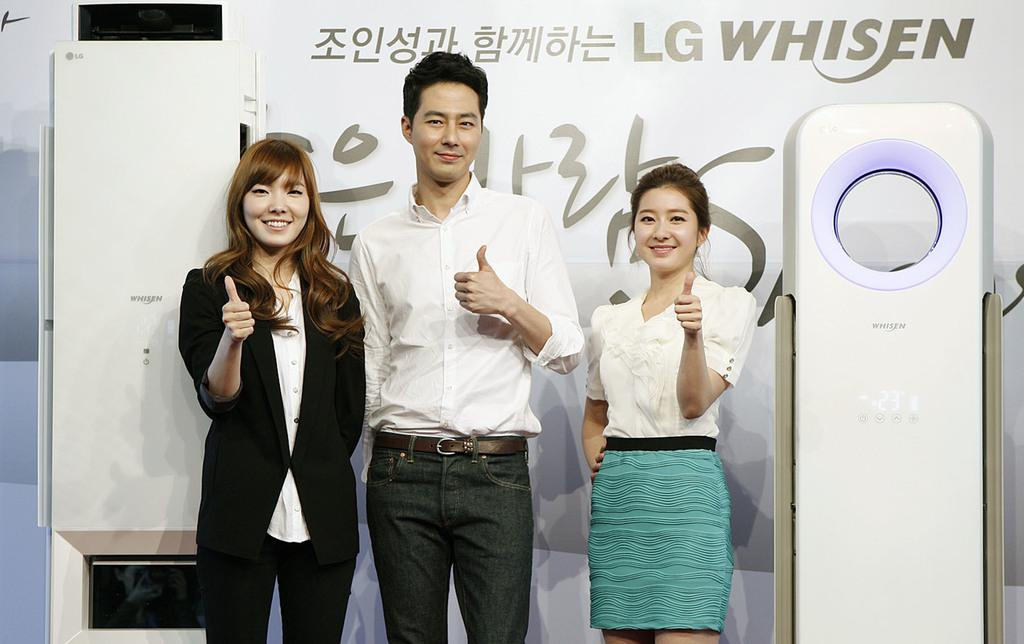How many people are present in the image? There are three people in the image. What expressions do the people have on their faces? The people are wearing smiles on their faces. What can be seen hanging or displayed in the image? There is a banner visible in the image. What type of objects are present that require electricity to function? There are electronic devices in the image. How many kittens are playing on the desk in the image? There are no kittens or desks present in the image. What type of tramp is visible in the image? There is no tramp present in the image. 